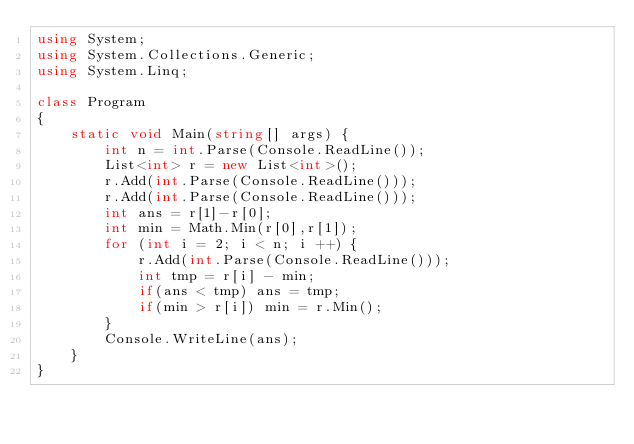Convert code to text. <code><loc_0><loc_0><loc_500><loc_500><_C#_>using System;
using System.Collections.Generic;
using System.Linq;

class Program
{
    static void Main(string[] args) {
        int n = int.Parse(Console.ReadLine());
        List<int> r = new List<int>();
        r.Add(int.Parse(Console.ReadLine()));
        r.Add(int.Parse(Console.ReadLine()));
        int ans = r[1]-r[0];
        int min = Math.Min(r[0],r[1]);
        for (int i = 2; i < n; i ++) {
            r.Add(int.Parse(Console.ReadLine()));
            int tmp = r[i] - min;
            if(ans < tmp) ans = tmp;
            if(min > r[i]) min = r.Min();
        }
        Console.WriteLine(ans);
    }
}
</code> 